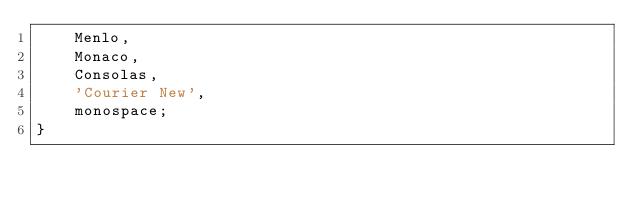<code> <loc_0><loc_0><loc_500><loc_500><_CSS_>    Menlo,
    Monaco,
    Consolas,
    'Courier New',
    monospace;
}
</code> 